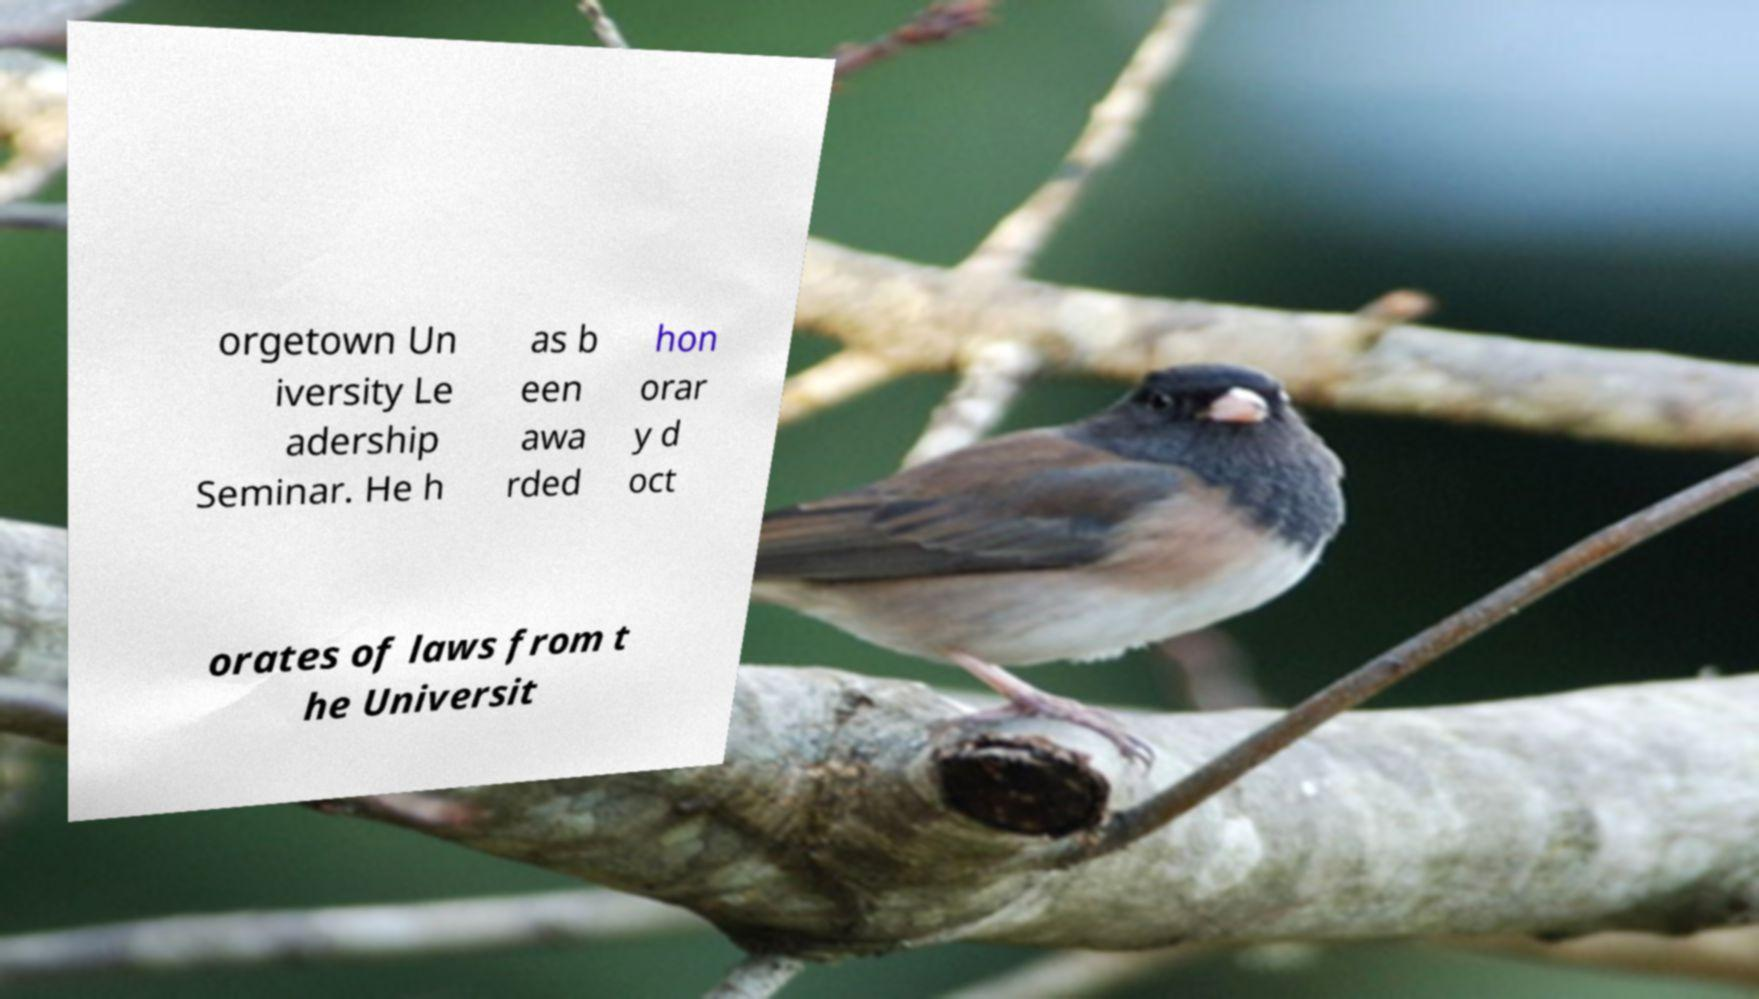There's text embedded in this image that I need extracted. Can you transcribe it verbatim? orgetown Un iversity Le adership Seminar. He h as b een awa rded hon orar y d oct orates of laws from t he Universit 